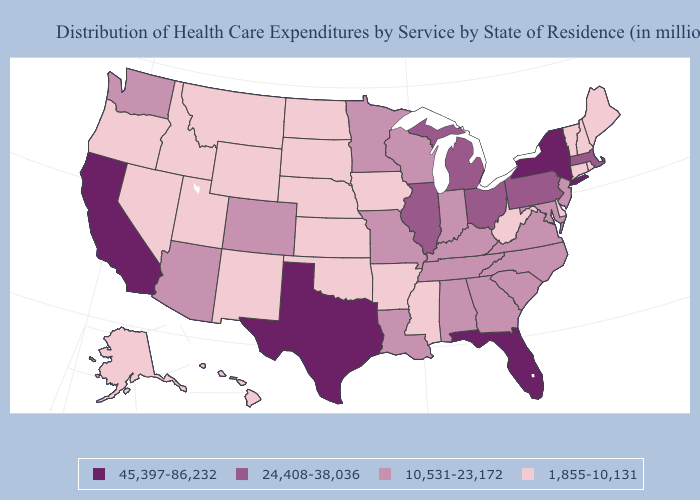What is the highest value in the USA?
Quick response, please. 45,397-86,232. Name the states that have a value in the range 24,408-38,036?
Concise answer only. Illinois, Massachusetts, Michigan, Ohio, Pennsylvania. Name the states that have a value in the range 1,855-10,131?
Answer briefly. Alaska, Arkansas, Connecticut, Delaware, Hawaii, Idaho, Iowa, Kansas, Maine, Mississippi, Montana, Nebraska, Nevada, New Hampshire, New Mexico, North Dakota, Oklahoma, Oregon, Rhode Island, South Dakota, Utah, Vermont, West Virginia, Wyoming. What is the value of Arkansas?
Concise answer only. 1,855-10,131. What is the value of Mississippi?
Quick response, please. 1,855-10,131. What is the value of Rhode Island?
Answer briefly. 1,855-10,131. What is the highest value in the West ?
Be succinct. 45,397-86,232. Among the states that border Kentucky , which have the highest value?
Write a very short answer. Illinois, Ohio. Name the states that have a value in the range 10,531-23,172?
Be succinct. Alabama, Arizona, Colorado, Georgia, Indiana, Kentucky, Louisiana, Maryland, Minnesota, Missouri, New Jersey, North Carolina, South Carolina, Tennessee, Virginia, Washington, Wisconsin. Does California have the highest value in the USA?
Write a very short answer. Yes. Is the legend a continuous bar?
Quick response, please. No. What is the lowest value in states that border Iowa?
Write a very short answer. 1,855-10,131. What is the value of West Virginia?
Concise answer only. 1,855-10,131. What is the value of Georgia?
Short answer required. 10,531-23,172. What is the lowest value in the USA?
Concise answer only. 1,855-10,131. 